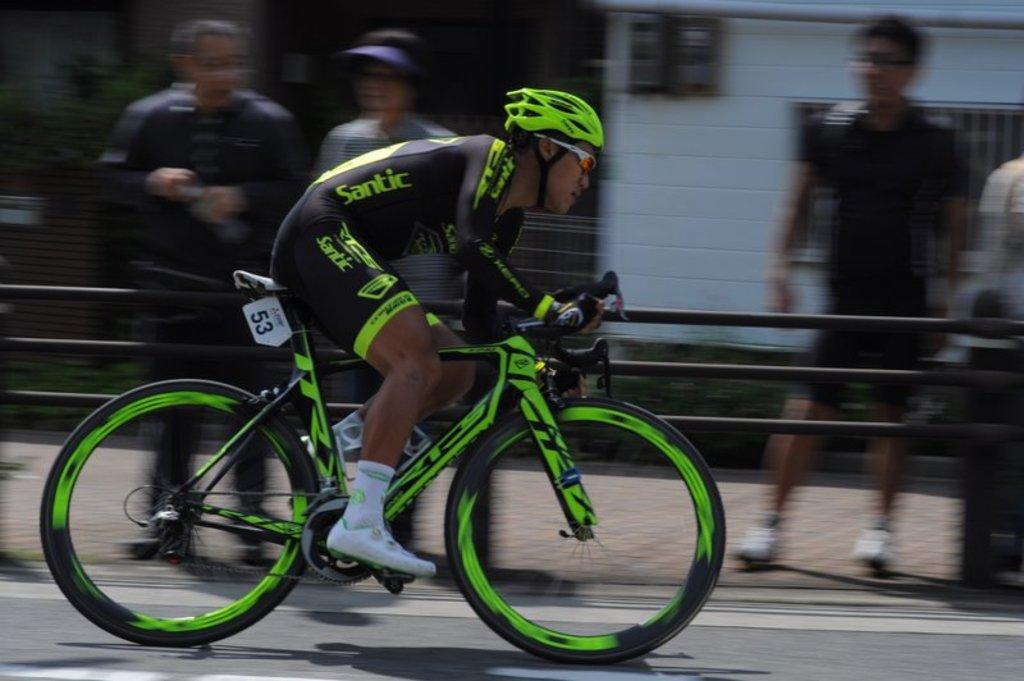Who is the main subject in the image? There is a man in the image. What is the man doing in the image? The man is riding a bicycle. What type of event is taking place in the image? The event is a sports event. Can you describe the surroundings in the image? There are people in the background of the image. What is the record time for the turkey race in the image? There is no turkey race present in the image; it features a man riding a bicycle in a sports event. Can you tell me how many buckets are being used by the man in the image? There are no buckets visible in the image; the man is riding a bicycle. 